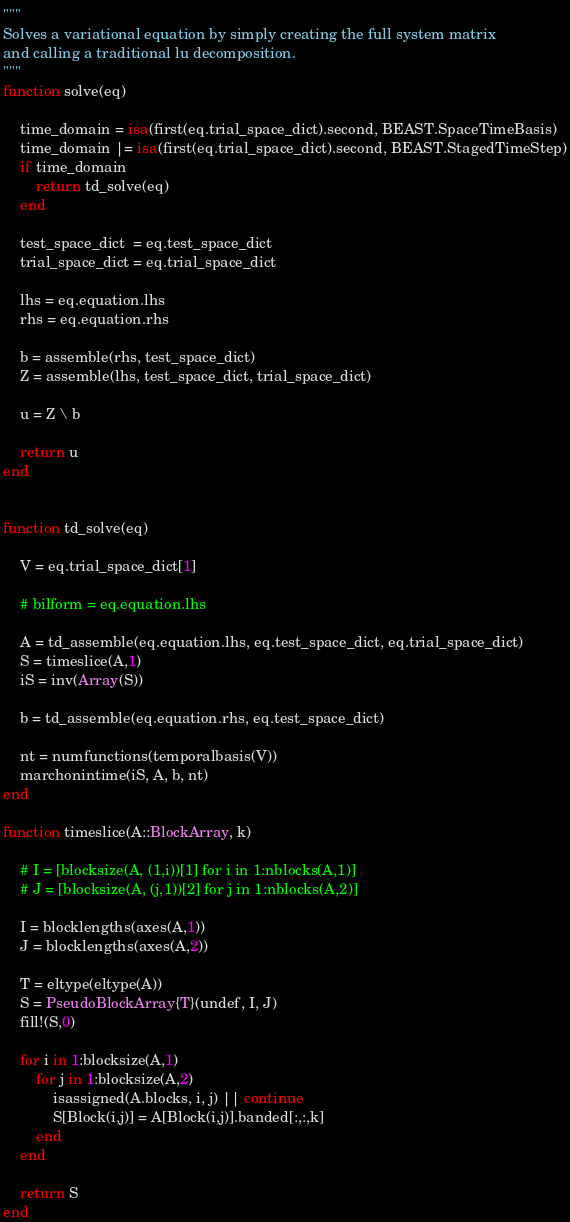Convert code to text. <code><loc_0><loc_0><loc_500><loc_500><_Julia_>"""
Solves a variational equation by simply creating the full system matrix
and calling a traditional lu decomposition.
"""
function solve(eq)

    time_domain = isa(first(eq.trial_space_dict).second, BEAST.SpaceTimeBasis)
    time_domain |= isa(first(eq.trial_space_dict).second, BEAST.StagedTimeStep)
    if time_domain
        return td_solve(eq)
    end

    test_space_dict  = eq.test_space_dict
    trial_space_dict = eq.trial_space_dict

    lhs = eq.equation.lhs
    rhs = eq.equation.rhs

    b = assemble(rhs, test_space_dict)
    Z = assemble(lhs, test_space_dict, trial_space_dict)

    u = Z \ b

    return u
end


function td_solve(eq)

    V = eq.trial_space_dict[1]

    # bilform = eq.equation.lhs

    A = td_assemble(eq.equation.lhs, eq.test_space_dict, eq.trial_space_dict)
    S = timeslice(A,1)
    iS = inv(Array(S))

    b = td_assemble(eq.equation.rhs, eq.test_space_dict)

    nt = numfunctions(temporalbasis(V))
    marchonintime(iS, A, b, nt)
end

function timeslice(A::BlockArray, k)

    # I = [blocksize(A, (1,i))[1] for i in 1:nblocks(A,1)]
    # J = [blocksize(A, (j,1))[2] for j in 1:nblocks(A,2)]

    I = blocklengths(axes(A,1))
    J = blocklengths(axes(A,2))

    T = eltype(eltype(A))
    S = PseudoBlockArray{T}(undef, I, J)
    fill!(S,0)

    for i in 1:blocksize(A,1)
        for j in 1:blocksize(A,2)
            isassigned(A.blocks, i, j) || continue
            S[Block(i,j)] = A[Block(i,j)].banded[:,:,k]
        end
    end

    return S
end
</code> 